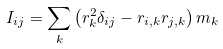<formula> <loc_0><loc_0><loc_500><loc_500>I _ { i j } = \sum _ { k } \left ( r _ { k } ^ { 2 } \delta _ { i j } - r _ { i , k } r _ { j , k } \right ) m _ { k }</formula> 